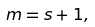Convert formula to latex. <formula><loc_0><loc_0><loc_500><loc_500>m = s + 1 ,</formula> 